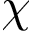Convert formula to latex. <formula><loc_0><loc_0><loc_500><loc_500>\chi</formula> 